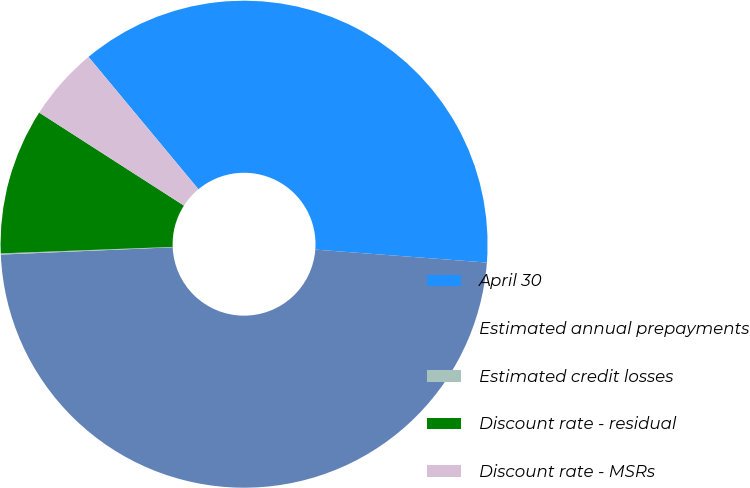Convert chart to OTSL. <chart><loc_0><loc_0><loc_500><loc_500><pie_chart><fcel>April 30<fcel>Estimated annual prepayments<fcel>Estimated credit losses<fcel>Discount rate - residual<fcel>Discount rate - MSRs<nl><fcel>37.23%<fcel>48.12%<fcel>0.08%<fcel>9.69%<fcel>4.88%<nl></chart> 